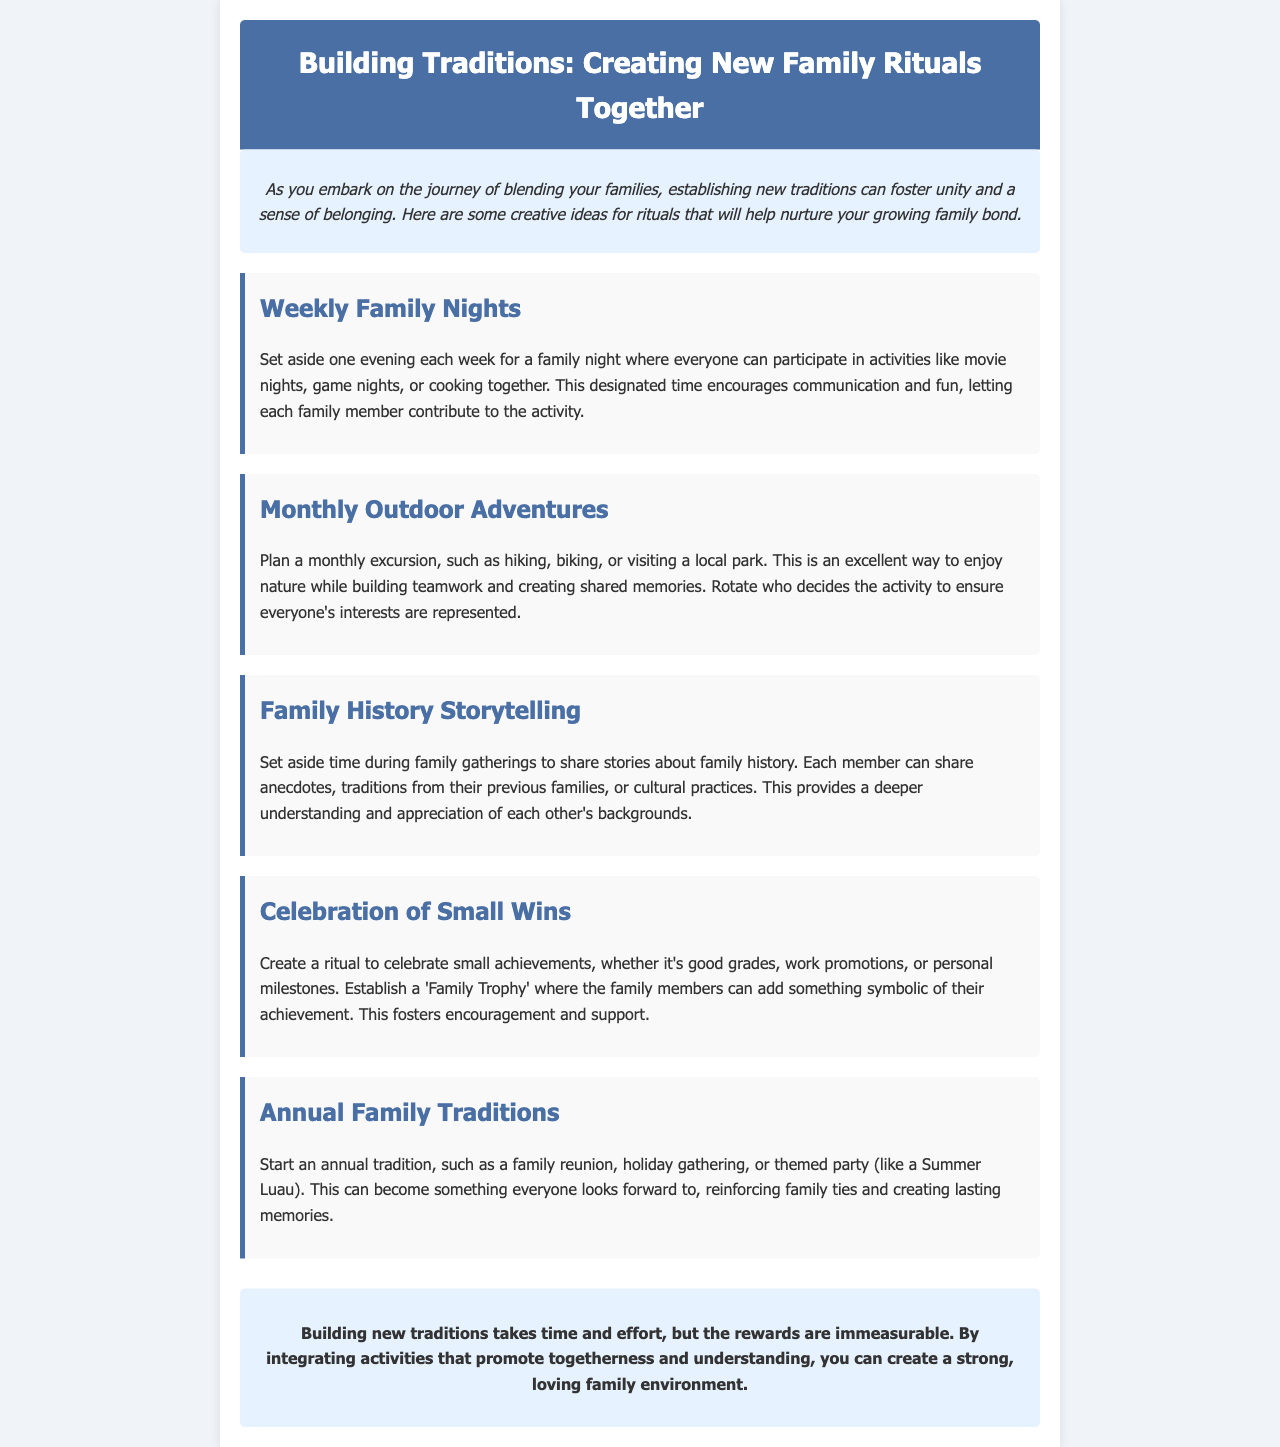What is the title of the document? The title is explicitly mentioned in the header section of the document.
Answer: Building Traditions: Creating New Family Rituals Together How many types of family activities are mentioned? The document lists different types of family activities under specific sections, which can be counted.
Answer: Five What is one suggested activity for family nights? The document provides examples of activities that can be done during family nights, specifically mentioning one.
Answer: Game nights What is a ritual for celebrating accomplishments? The document describes a specific way to celebrate small achievements within the family context.
Answer: Family Trophy What is the suggested frequency for outdoor adventures? The document specifies how often to plan outdoor excursions, which can be found in the section dedicated to this topic.
Answer: Monthly What is an example of an annual tradition? The document lists different types of annual traditions that can be established, asking for one specific example.
Answer: Family reunion Why are family history storytelling sessions important? The document explains the significance of sharing family history and its benefits.
Answer: Understanding and appreciation What is the primary goal of creating new family rituals? The document mentions the overall purpose of establishing new traditions for families.
Answer: Unity and belonging 